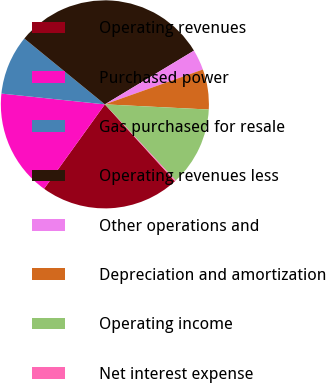Convert chart. <chart><loc_0><loc_0><loc_500><loc_500><pie_chart><fcel>Operating revenues<fcel>Purchased power<fcel>Gas purchased for resale<fcel>Operating revenues less<fcel>Other operations and<fcel>Depreciation and amortization<fcel>Operating income<fcel>Net interest expense<nl><fcel>21.69%<fcel>16.72%<fcel>9.25%<fcel>30.46%<fcel>3.2%<fcel>6.23%<fcel>12.28%<fcel>0.17%<nl></chart> 